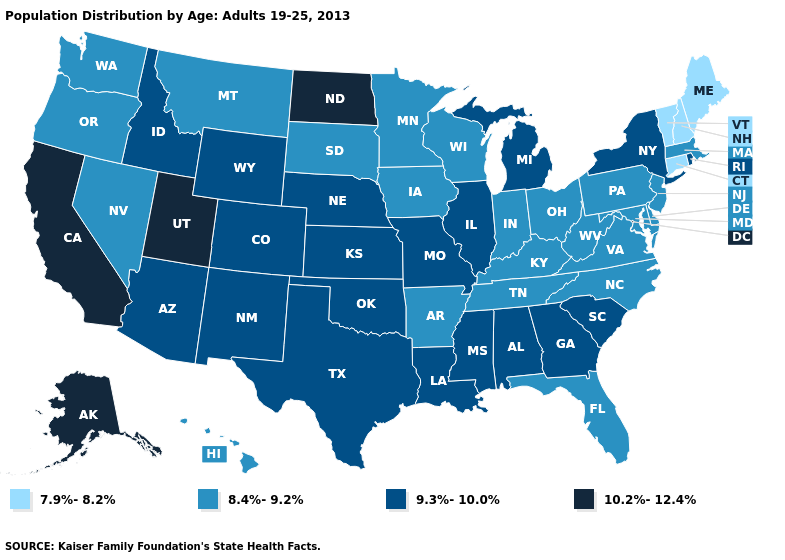Does the map have missing data?
Keep it brief. No. What is the value of Alabama?
Keep it brief. 9.3%-10.0%. Which states hav the highest value in the South?
Answer briefly. Alabama, Georgia, Louisiana, Mississippi, Oklahoma, South Carolina, Texas. Among the states that border Connecticut , which have the lowest value?
Concise answer only. Massachusetts. What is the highest value in the West ?
Write a very short answer. 10.2%-12.4%. Among the states that border Montana , which have the highest value?
Write a very short answer. North Dakota. Name the states that have a value in the range 9.3%-10.0%?
Concise answer only. Alabama, Arizona, Colorado, Georgia, Idaho, Illinois, Kansas, Louisiana, Michigan, Mississippi, Missouri, Nebraska, New Mexico, New York, Oklahoma, Rhode Island, South Carolina, Texas, Wyoming. Name the states that have a value in the range 8.4%-9.2%?
Short answer required. Arkansas, Delaware, Florida, Hawaii, Indiana, Iowa, Kentucky, Maryland, Massachusetts, Minnesota, Montana, Nevada, New Jersey, North Carolina, Ohio, Oregon, Pennsylvania, South Dakota, Tennessee, Virginia, Washington, West Virginia, Wisconsin. Name the states that have a value in the range 7.9%-8.2%?
Concise answer only. Connecticut, Maine, New Hampshire, Vermont. What is the value of Virginia?
Keep it brief. 8.4%-9.2%. What is the value of Texas?
Keep it brief. 9.3%-10.0%. Which states have the lowest value in the USA?
Be succinct. Connecticut, Maine, New Hampshire, Vermont. Does the map have missing data?
Keep it brief. No. What is the value of North Carolina?
Give a very brief answer. 8.4%-9.2%. Does the map have missing data?
Be succinct. No. 